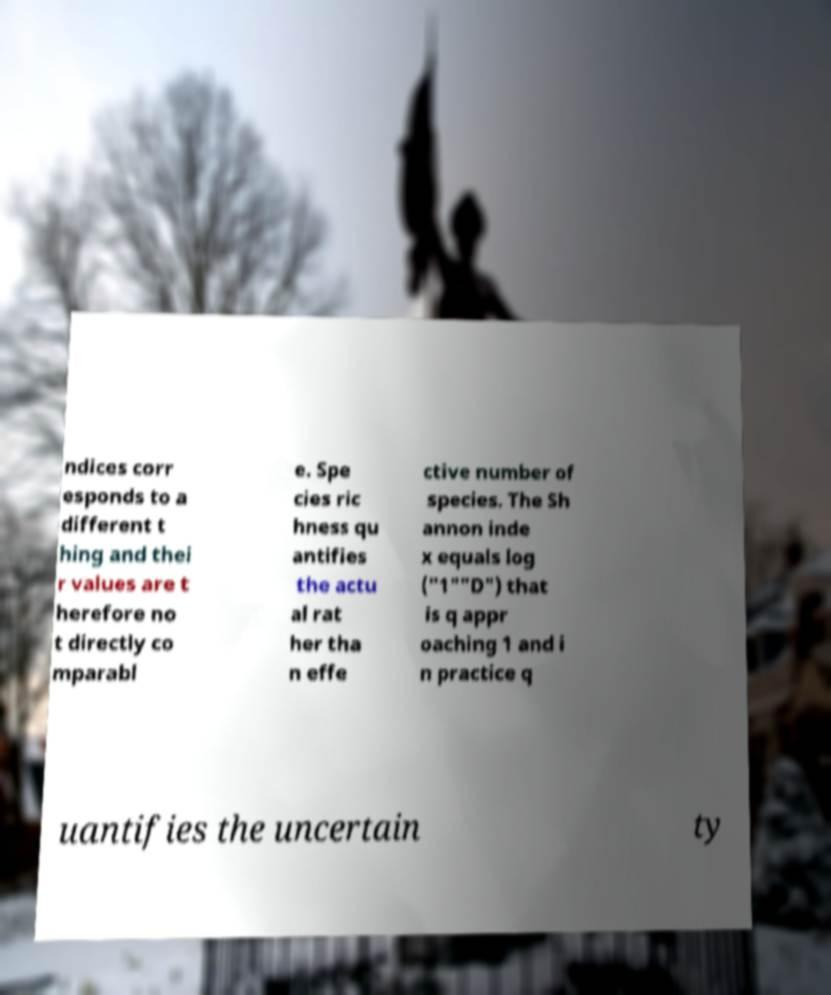For documentation purposes, I need the text within this image transcribed. Could you provide that? ndices corr esponds to a different t hing and thei r values are t herefore no t directly co mparabl e. Spe cies ric hness qu antifies the actu al rat her tha n effe ctive number of species. The Sh annon inde x equals log ("1""D") that is q appr oaching 1 and i n practice q uantifies the uncertain ty 